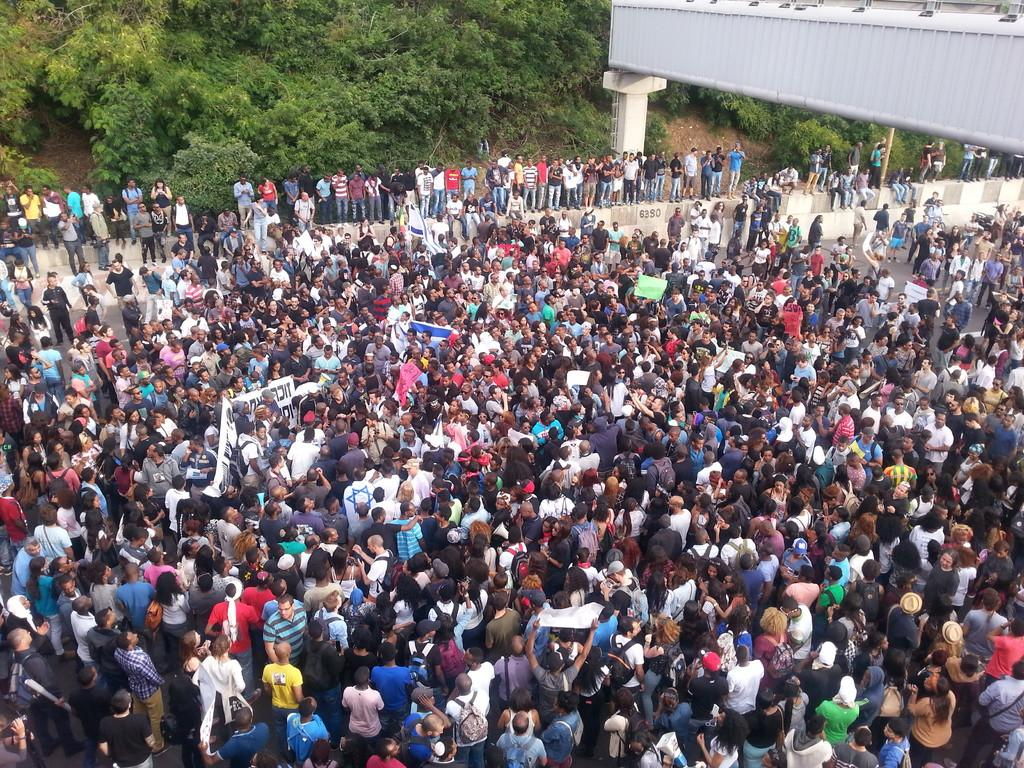What type of gathering is depicted in the image? There is a crowd in the image, suggesting a gathering of people. Can you describe the composition of the crowd? There are both men and women in the image. What architectural feature can be seen in the image? There is a pillar in the image. What can be seen in the background of the image? There are trees in the background of the image. How many chickens are visible in the image? There are no chickens present in the image. What angle is the camera positioned at in the image? The angle of the camera cannot be determined from the image alone. 